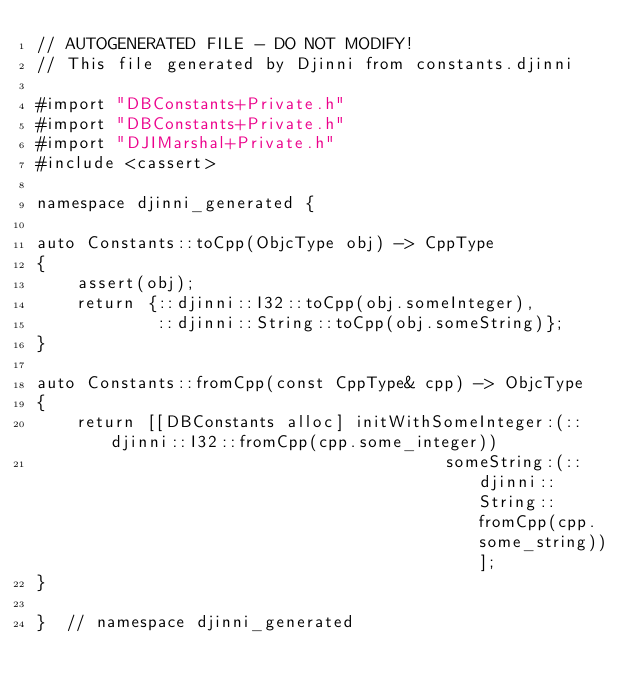Convert code to text. <code><loc_0><loc_0><loc_500><loc_500><_ObjectiveC_>// AUTOGENERATED FILE - DO NOT MODIFY!
// This file generated by Djinni from constants.djinni

#import "DBConstants+Private.h"
#import "DBConstants+Private.h"
#import "DJIMarshal+Private.h"
#include <cassert>

namespace djinni_generated {

auto Constants::toCpp(ObjcType obj) -> CppType
{
    assert(obj);
    return {::djinni::I32::toCpp(obj.someInteger),
            ::djinni::String::toCpp(obj.someString)};
}

auto Constants::fromCpp(const CppType& cpp) -> ObjcType
{
    return [[DBConstants alloc] initWithSomeInteger:(::djinni::I32::fromCpp(cpp.some_integer))
                                         someString:(::djinni::String::fromCpp(cpp.some_string))];
}

}  // namespace djinni_generated
</code> 